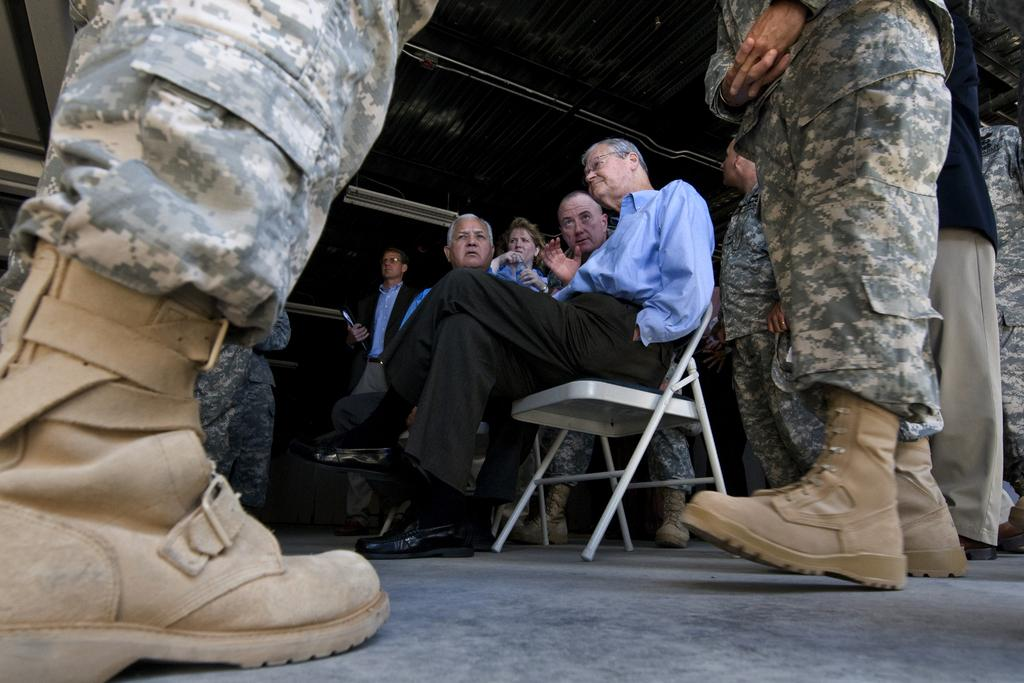How many people are sitting on the chair in the image? There are two people sitting on a chair in the image. What are the two people doing? The two people are having a conversation. What can be seen on the right side of the image? There is a soldier on the right side of the image. What is present on the left side of the image? There is a soldier's shoe on the left side of the image. What type of clock is visible in the image? There is no clock present in the image. What color is the soldier's tongue in the image? There is no soldier's tongue visible in the image. 